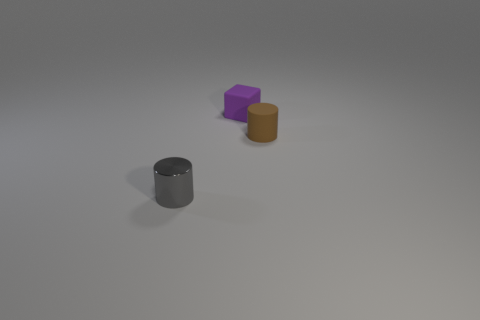Subtract all gray cylinders. How many cylinders are left? 1 Subtract all cubes. How many objects are left? 2 Subtract 1 blocks. How many blocks are left? 0 Add 2 blue cylinders. How many objects exist? 5 Subtract 0 gray cubes. How many objects are left? 3 Subtract all purple cylinders. Subtract all blue spheres. How many cylinders are left? 2 Subtract all cyan cylinders. How many red blocks are left? 0 Subtract all large red cylinders. Subtract all gray metal things. How many objects are left? 2 Add 1 purple things. How many purple things are left? 2 Add 1 small purple blocks. How many small purple blocks exist? 2 